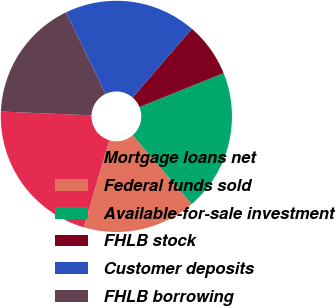Convert chart to OTSL. <chart><loc_0><loc_0><loc_500><loc_500><pie_chart><fcel>Mortgage loans net<fcel>Federal funds sold<fcel>Available-for-sale investment<fcel>FHLB stock<fcel>Customer deposits<fcel>FHLB borrowing<nl><fcel>21.12%<fcel>15.84%<fcel>19.8%<fcel>7.58%<fcel>18.48%<fcel>17.16%<nl></chart> 